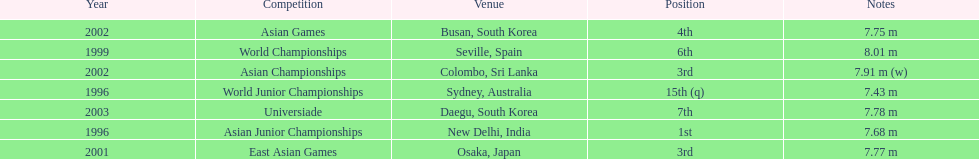What was the only competition where this competitor achieved 1st place? Asian Junior Championships. 